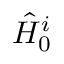Convert formula to latex. <formula><loc_0><loc_0><loc_500><loc_500>\hat { H } _ { 0 } ^ { i }</formula> 